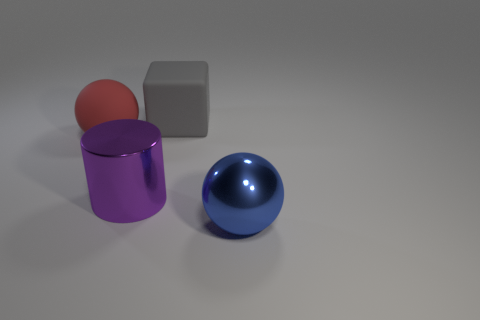Are there more balls behind the large purple object than small green rubber spheres?
Provide a succinct answer. Yes. There is a large red rubber object; is it the same shape as the thing that is right of the gray cube?
Make the answer very short. Yes. Is there a gray thing?
Offer a very short reply. Yes. How many large objects are either red objects or cyan shiny blocks?
Offer a terse response. 1. Are there more big gray rubber cubes that are in front of the big blue sphere than red balls behind the cube?
Ensure brevity in your answer.  No. Is the material of the large red thing the same as the thing in front of the metallic cylinder?
Offer a very short reply. No. The big rubber block has what color?
Ensure brevity in your answer.  Gray. What shape is the big metallic object that is behind the metallic ball?
Provide a short and direct response. Cylinder. How many red objects are either large blocks or big metal cylinders?
Provide a short and direct response. 0. What is the color of the large cylinder that is the same material as the big blue object?
Give a very brief answer. Purple. 